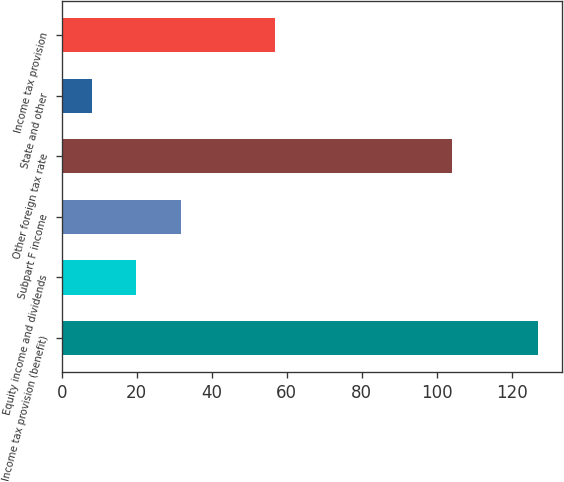<chart> <loc_0><loc_0><loc_500><loc_500><bar_chart><fcel>Income tax provision (benefit)<fcel>Equity income and dividends<fcel>Subpart F income<fcel>Other foreign tax rate<fcel>State and other<fcel>Income tax provision<nl><fcel>127<fcel>19.9<fcel>31.8<fcel>104<fcel>8<fcel>57<nl></chart> 